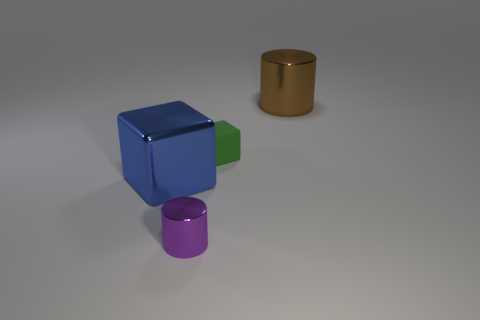What number of cylinders are there?
Your answer should be very brief. 2. There is a big metallic object on the left side of the small matte object; what is its color?
Your response must be concise. Blue. The cylinder left of the cylinder behind the small purple metal cylinder is what color?
Provide a short and direct response. Purple. There is a metallic object that is the same size as the brown shiny cylinder; what color is it?
Your response must be concise. Blue. How many big metal objects are both in front of the rubber object and on the right side of the blue metallic cube?
Your answer should be very brief. 0. What material is the object that is both in front of the brown metallic cylinder and to the right of the tiny metal cylinder?
Your response must be concise. Rubber. Are there fewer tiny green objects to the right of the tiny matte object than shiny things that are behind the large blue object?
Your response must be concise. Yes. What is the size of the brown thing that is the same material as the blue object?
Provide a short and direct response. Large. Is there anything else that is the same color as the large shiny block?
Provide a short and direct response. No. Does the tiny purple thing have the same material as the cylinder behind the tiny purple thing?
Your answer should be very brief. Yes. 